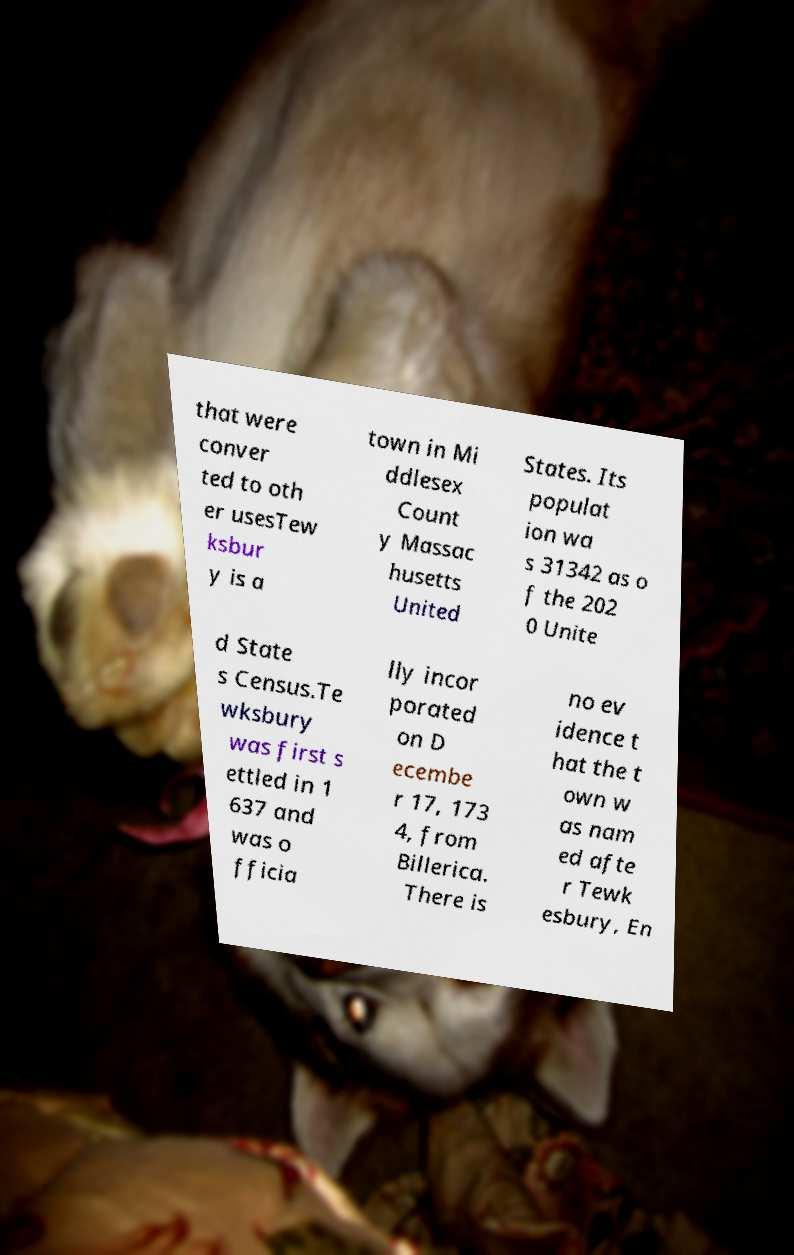Could you assist in decoding the text presented in this image and type it out clearly? that were conver ted to oth er usesTew ksbur y is a town in Mi ddlesex Count y Massac husetts United States. Its populat ion wa s 31342 as o f the 202 0 Unite d State s Census.Te wksbury was first s ettled in 1 637 and was o fficia lly incor porated on D ecembe r 17, 173 4, from Billerica. There is no ev idence t hat the t own w as nam ed afte r Tewk esbury, En 